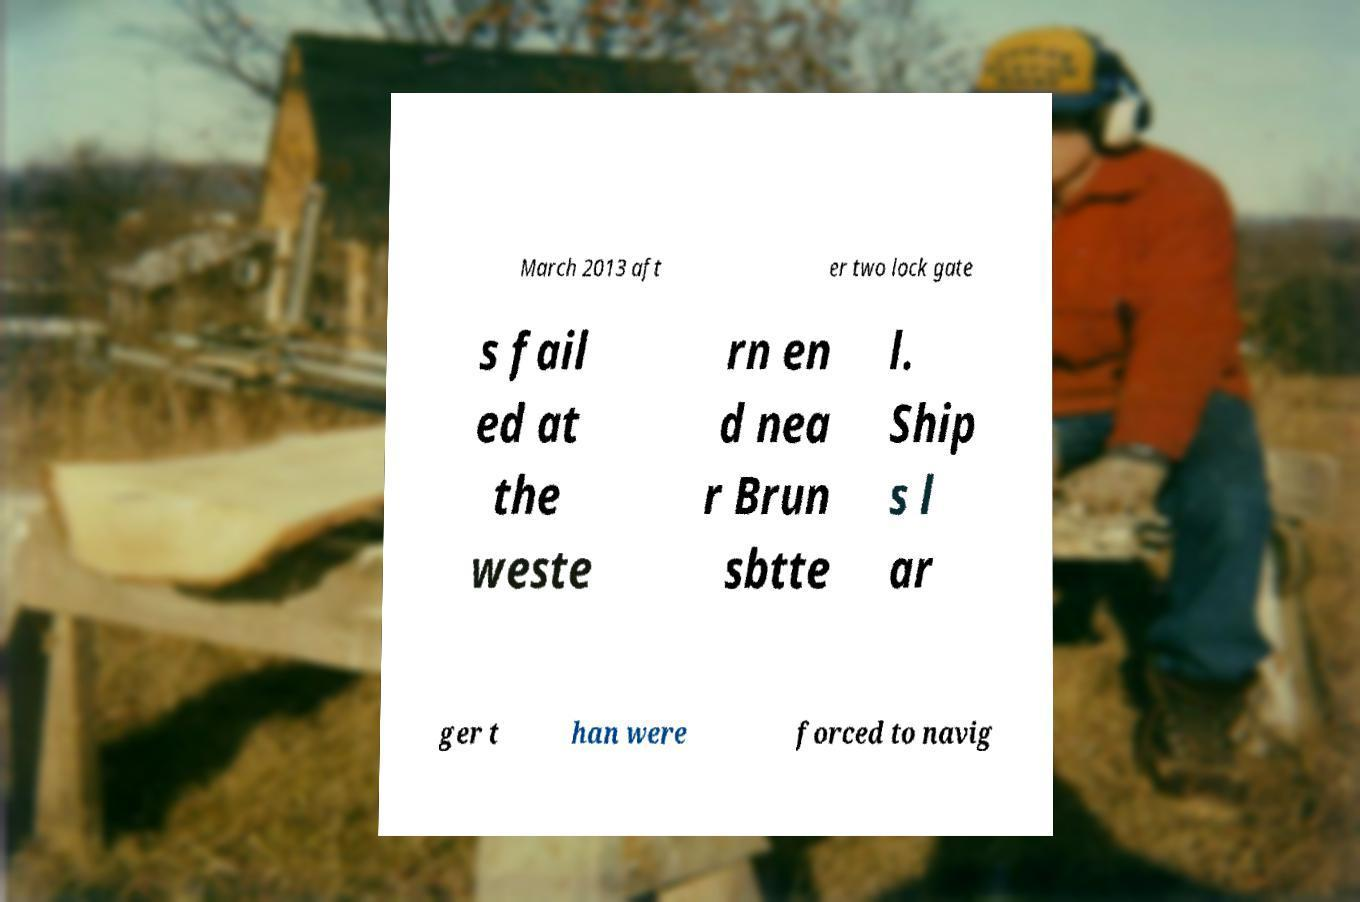Please read and relay the text visible in this image. What does it say? March 2013 aft er two lock gate s fail ed at the weste rn en d nea r Brun sbtte l. Ship s l ar ger t han were forced to navig 